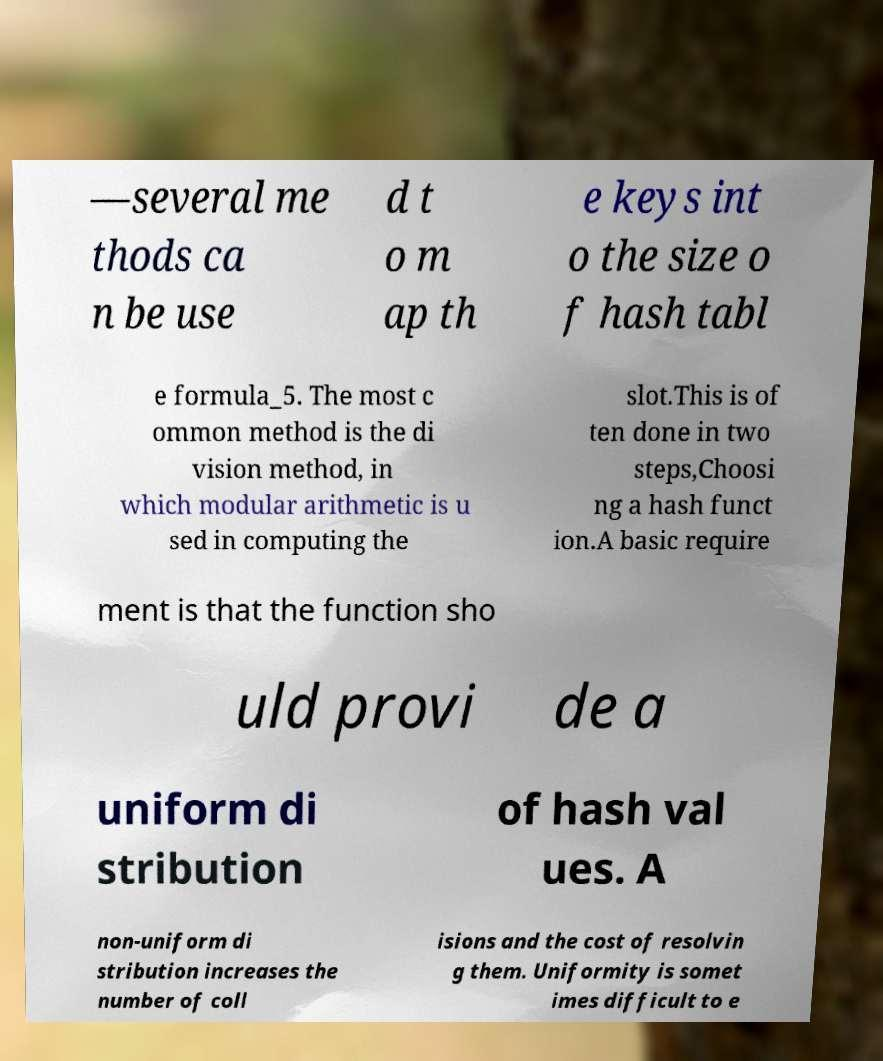Can you accurately transcribe the text from the provided image for me? —several me thods ca n be use d t o m ap th e keys int o the size o f hash tabl e formula_5. The most c ommon method is the di vision method, in which modular arithmetic is u sed in computing the slot.This is of ten done in two steps,Choosi ng a hash funct ion.A basic require ment is that the function sho uld provi de a uniform di stribution of hash val ues. A non-uniform di stribution increases the number of coll isions and the cost of resolvin g them. Uniformity is somet imes difficult to e 